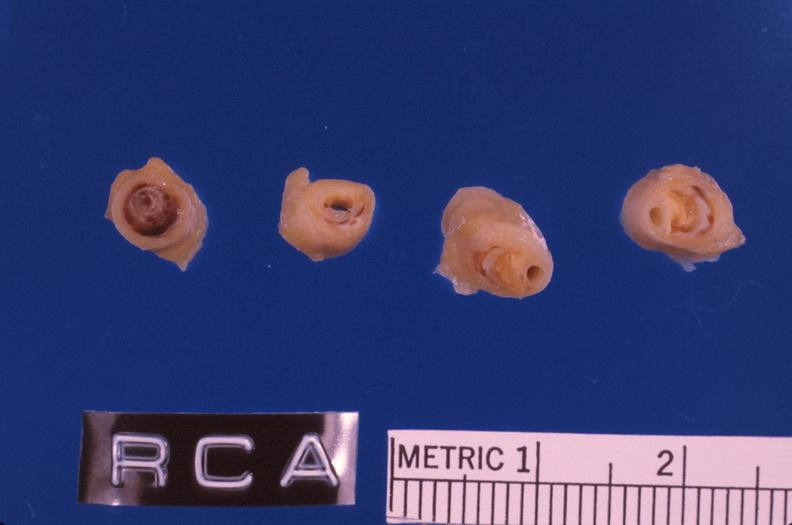what is present?
Answer the question using a single word or phrase. Vasculature 